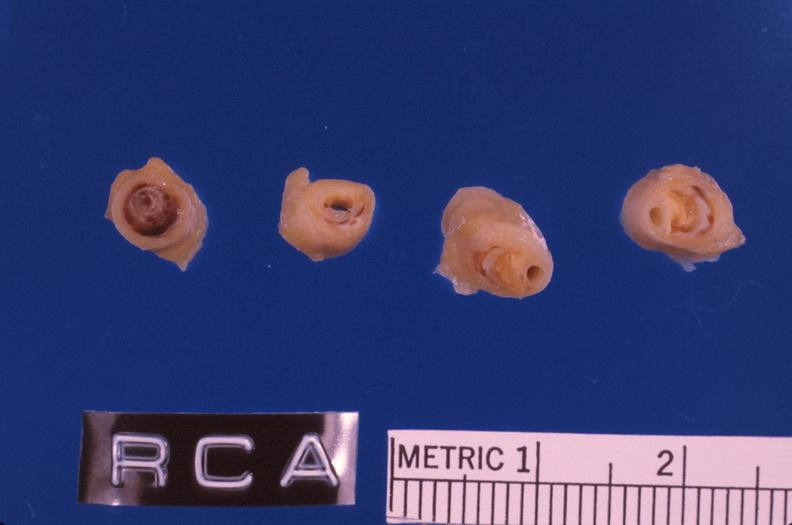what is present?
Answer the question using a single word or phrase. Vasculature 